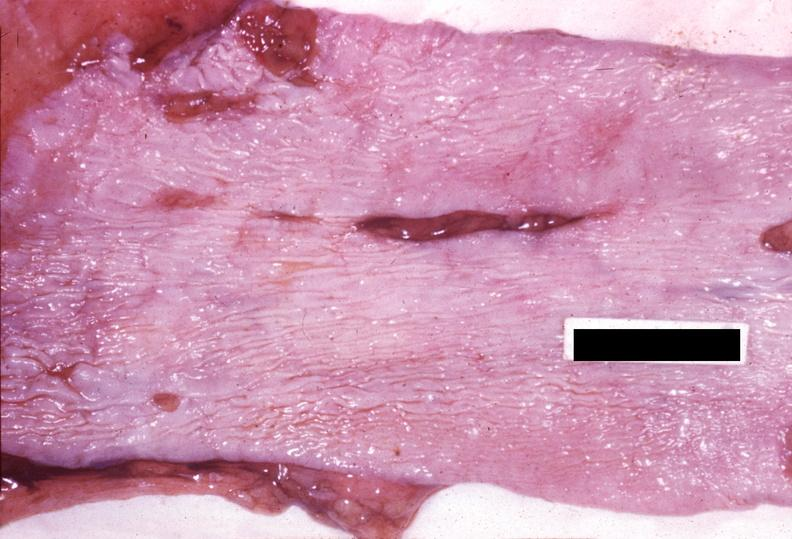where does this belong to?
Answer the question using a single word or phrase. Gastrointestinal system 